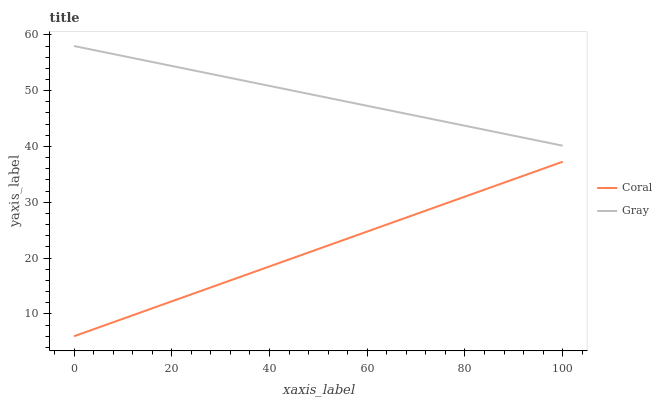Does Coral have the minimum area under the curve?
Answer yes or no. Yes. Does Gray have the maximum area under the curve?
Answer yes or no. Yes. Does Coral have the maximum area under the curve?
Answer yes or no. No. Is Coral the smoothest?
Answer yes or no. Yes. Is Gray the roughest?
Answer yes or no. Yes. Is Coral the roughest?
Answer yes or no. No. Does Coral have the highest value?
Answer yes or no. No. Is Coral less than Gray?
Answer yes or no. Yes. Is Gray greater than Coral?
Answer yes or no. Yes. Does Coral intersect Gray?
Answer yes or no. No. 